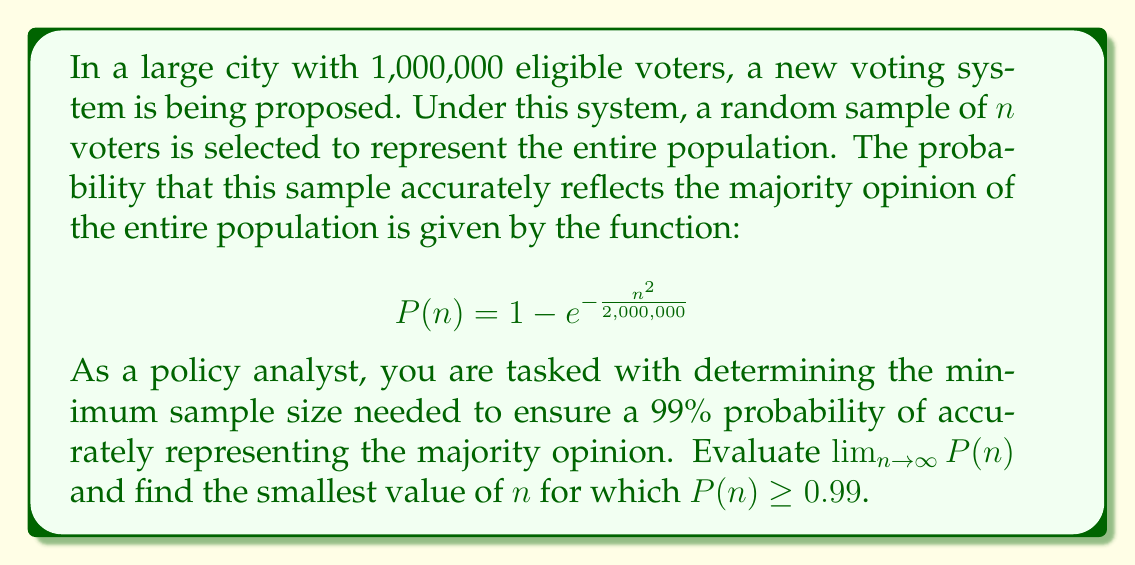Help me with this question. To solve this problem, we'll follow these steps:

1. Evaluate the limit of $P(n)$ as $n$ approaches infinity.
2. Set up an equation to find the minimum sample size for 99% accuracy.
3. Solve the equation for $n$.

Step 1: Evaluating $\lim_{n \to \infty} P(n)$

As $n$ approaches infinity, the exponent $-\frac{n^2}{2,000,000}$ approaches negative infinity. Therefore:

$$\lim_{n \to \infty} P(n) = \lim_{n \to \infty} (1 - e^{-\frac{n^2}{2,000,000}}) = 1 - \lim_{n \to \infty} e^{-\frac{n^2}{2,000,000}} = 1 - 0 = 1$$

This means that as the sample size increases, the probability of accurately representing the majority opinion approaches 1 (or 100%).

Step 2: Setting up the equation for 99% accuracy

We want to find $n$ such that $P(n) \geq 0.99$. Let's set up the equation:

$$1 - e^{-\frac{n^2}{2,000,000}} \geq 0.99$$

Step 3: Solving for $n$

Subtracting both sides from 1:

$$e^{-\frac{n^2}{2,000,000}} \leq 0.01$$

Taking the natural logarithm of both sides:

$$-\frac{n^2}{2,000,000} \leq \ln(0.01)$$

Multiplying both sides by -2,000,000:

$$n^2 \geq -2,000,000 \ln(0.01)$$

Taking the square root of both sides:

$$n \geq \sqrt{-2,000,000 \ln(0.01)} \approx 301.9$$

Since $n$ must be a whole number, we round up to the nearest integer.
Answer: The limit of $P(n)$ as $n$ approaches infinity is 1, and the minimum sample size needed to ensure a 99% probability of accurately representing the majority opinion is 302 voters. 